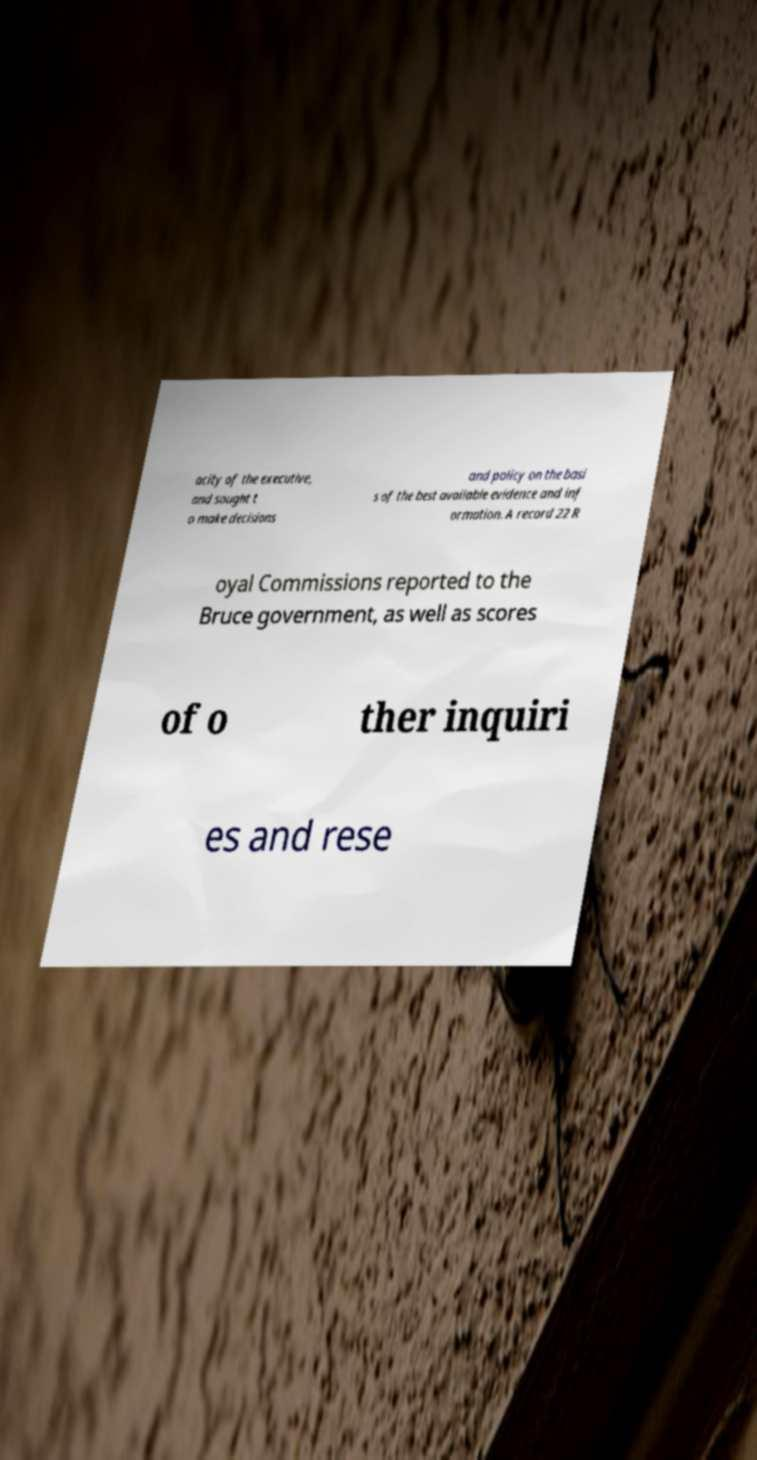Please read and relay the text visible in this image. What does it say? acity of the executive, and sought t o make decisions and policy on the basi s of the best available evidence and inf ormation. A record 22 R oyal Commissions reported to the Bruce government, as well as scores of o ther inquiri es and rese 